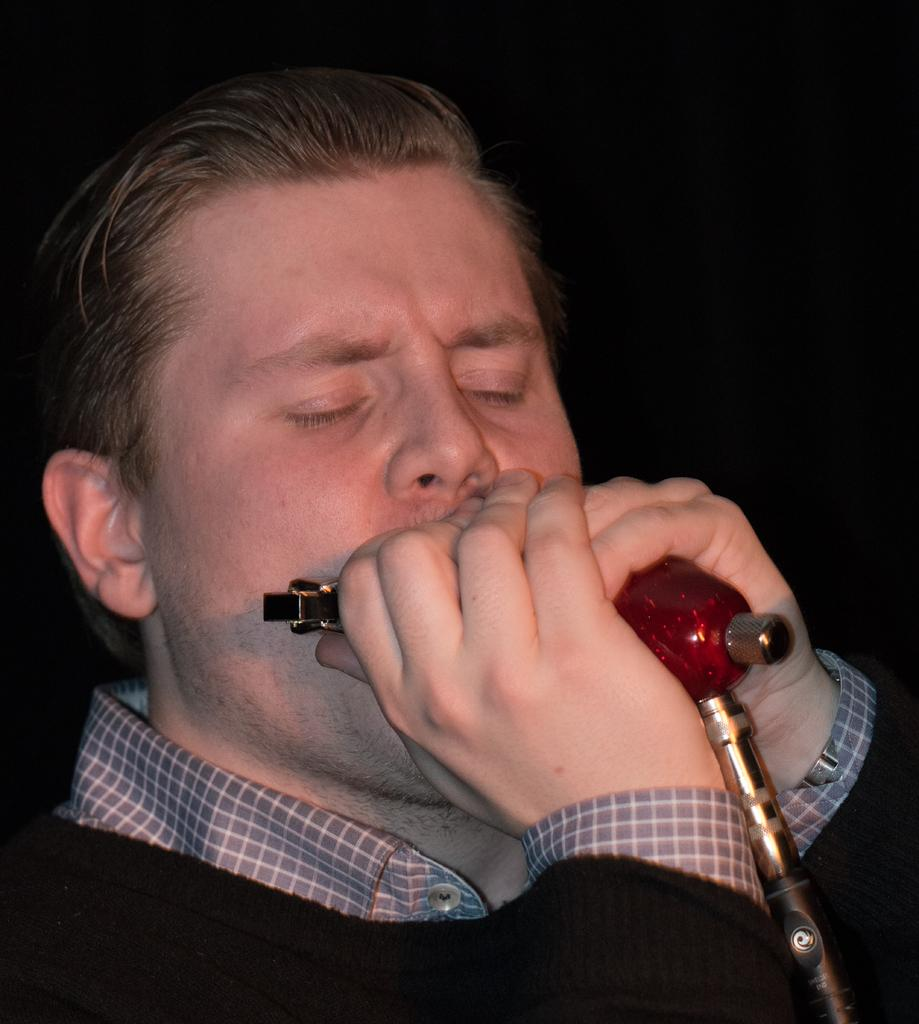What is the main subject of the image? There is a person in the image. What is the person doing in the image? The person is playing a musical instrument. What type of nut can be seen in the image? There is no nut present in the image. What is the texture of the person's suit in the image? The person is not wearing a suit in the image. 